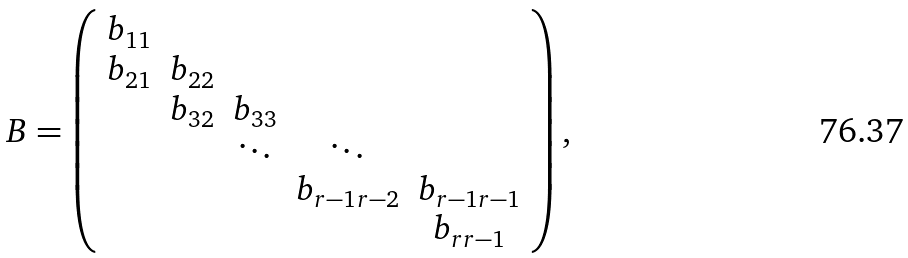<formula> <loc_0><loc_0><loc_500><loc_500>B = \left ( \begin{array} { c c c c c } b _ { 1 1 } & & & & \\ b _ { 2 1 } & b _ { 2 2 } & & & \\ & b _ { 3 2 } & b _ { 3 3 } & & \\ & & \ddots & \ddots & \\ & & & b _ { r - 1 r - 2 } & b _ { r - 1 r - 1 } \\ & & & & b _ { r r - 1 } \end{array} \right ) ,</formula> 